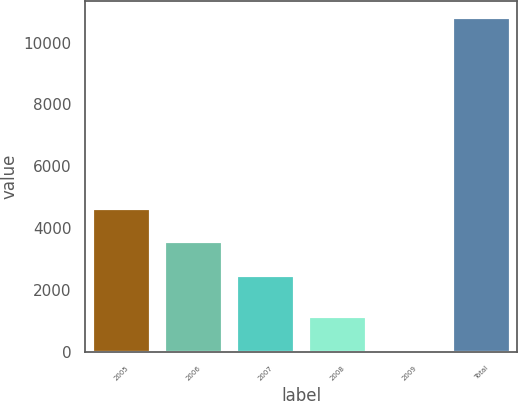<chart> <loc_0><loc_0><loc_500><loc_500><bar_chart><fcel>2005<fcel>2006<fcel>2007<fcel>2008<fcel>2009<fcel>Total<nl><fcel>4640.2<fcel>3568.1<fcel>2496<fcel>1162.1<fcel>90<fcel>10811<nl></chart> 